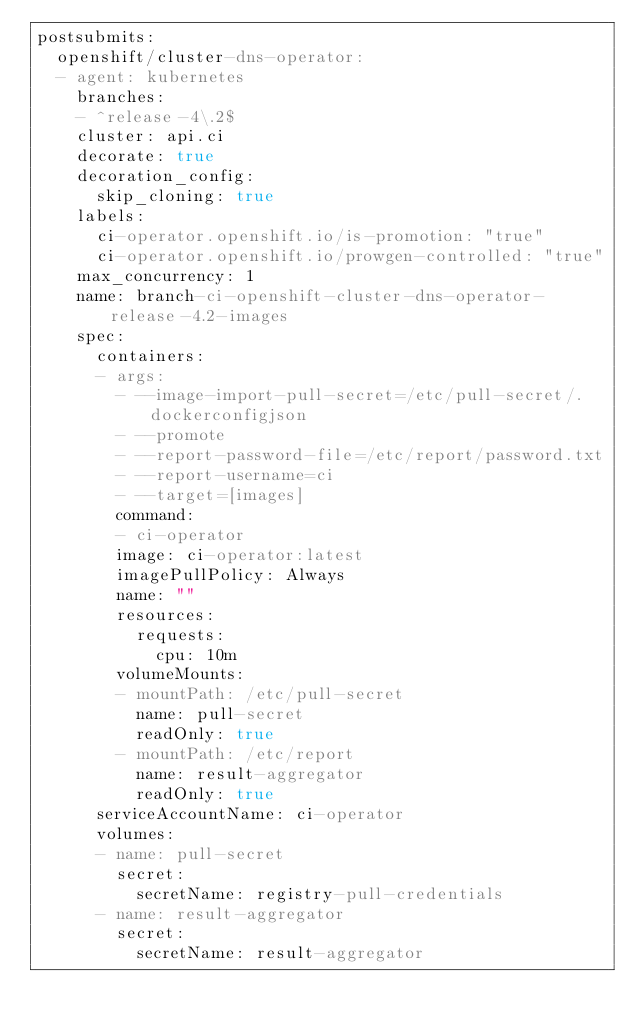<code> <loc_0><loc_0><loc_500><loc_500><_YAML_>postsubmits:
  openshift/cluster-dns-operator:
  - agent: kubernetes
    branches:
    - ^release-4\.2$
    cluster: api.ci
    decorate: true
    decoration_config:
      skip_cloning: true
    labels:
      ci-operator.openshift.io/is-promotion: "true"
      ci-operator.openshift.io/prowgen-controlled: "true"
    max_concurrency: 1
    name: branch-ci-openshift-cluster-dns-operator-release-4.2-images
    spec:
      containers:
      - args:
        - --image-import-pull-secret=/etc/pull-secret/.dockerconfigjson
        - --promote
        - --report-password-file=/etc/report/password.txt
        - --report-username=ci
        - --target=[images]
        command:
        - ci-operator
        image: ci-operator:latest
        imagePullPolicy: Always
        name: ""
        resources:
          requests:
            cpu: 10m
        volumeMounts:
        - mountPath: /etc/pull-secret
          name: pull-secret
          readOnly: true
        - mountPath: /etc/report
          name: result-aggregator
          readOnly: true
      serviceAccountName: ci-operator
      volumes:
      - name: pull-secret
        secret:
          secretName: registry-pull-credentials
      - name: result-aggregator
        secret:
          secretName: result-aggregator
</code> 